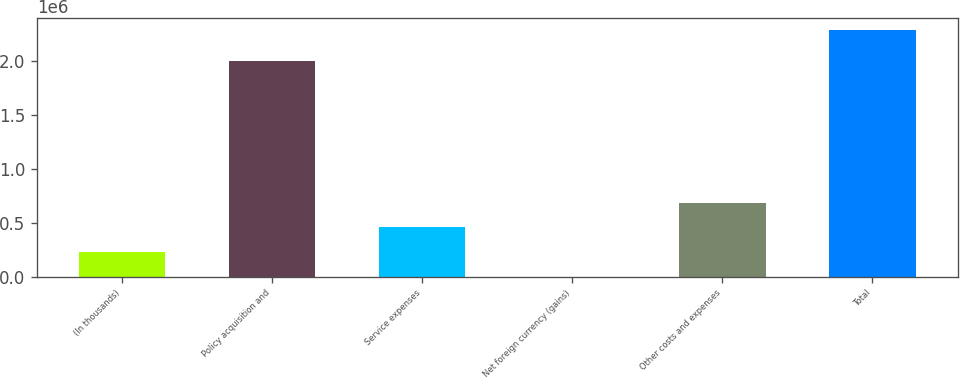Convert chart. <chart><loc_0><loc_0><loc_500><loc_500><bar_chart><fcel>(In thousands)<fcel>Policy acquisition and<fcel>Service expenses<fcel>Net foreign currency (gains)<fcel>Other costs and expenses<fcel>Total<nl><fcel>229335<fcel>2.0055e+06<fcel>458270<fcel>400<fcel>687205<fcel>2.28975e+06<nl></chart> 